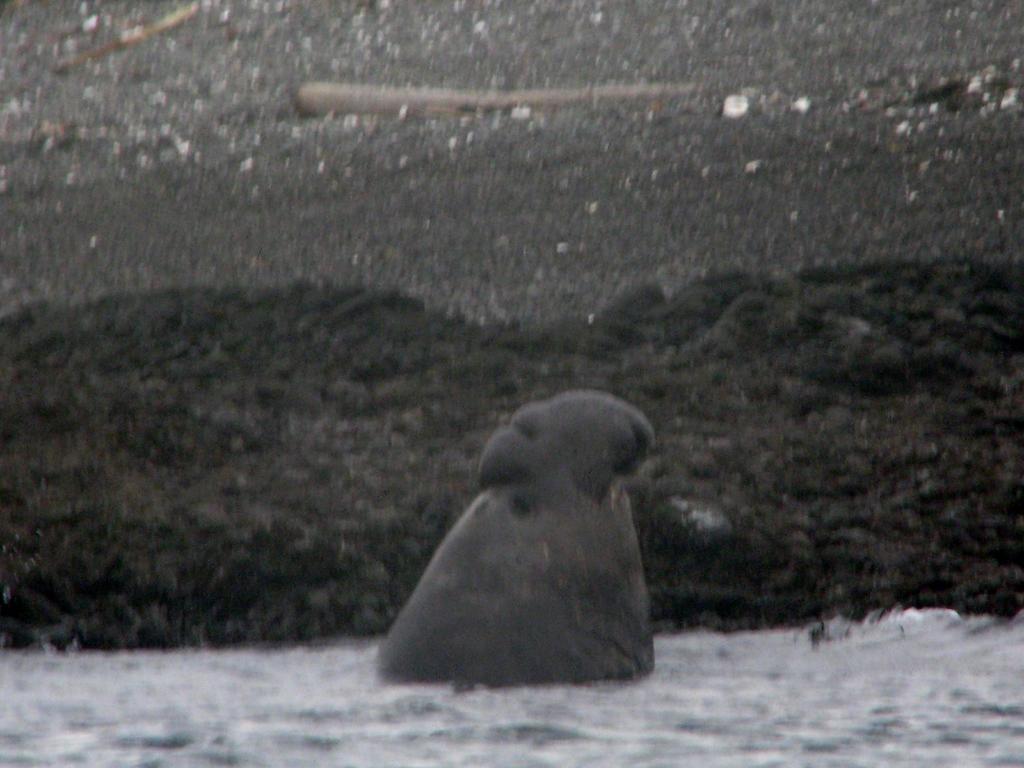How would you summarize this image in a sentence or two? It is a blur image. Here it's looks like an object in the water. Background we can see sand. 